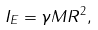<formula> <loc_0><loc_0><loc_500><loc_500>I _ { E } = \gamma M R ^ { 2 } ,</formula> 